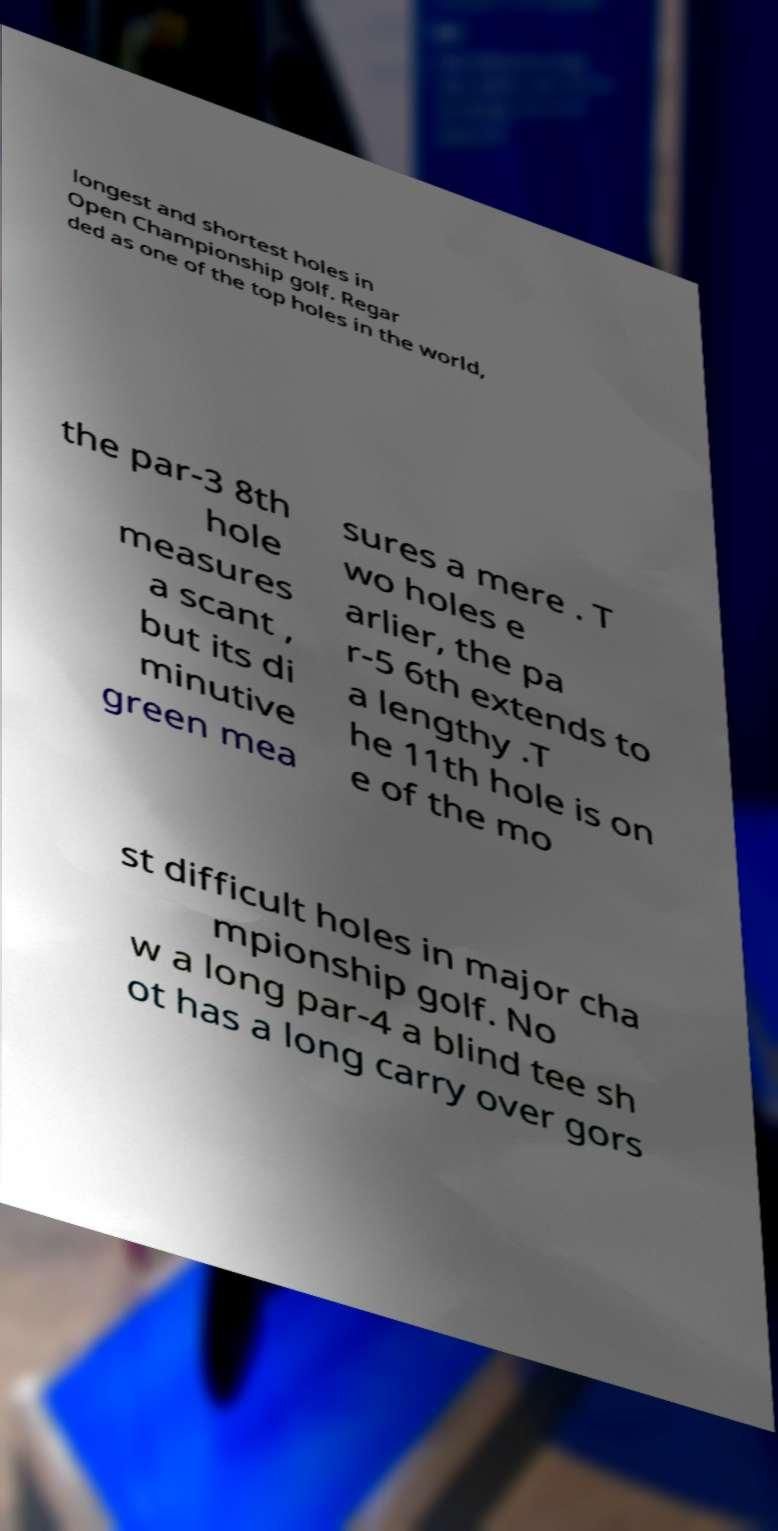What messages or text are displayed in this image? I need them in a readable, typed format. longest and shortest holes in Open Championship golf. Regar ded as one of the top holes in the world, the par-3 8th hole measures a scant , but its di minutive green mea sures a mere . T wo holes e arlier, the pa r-5 6th extends to a lengthy .T he 11th hole is on e of the mo st difficult holes in major cha mpionship golf. No w a long par-4 a blind tee sh ot has a long carry over gors 